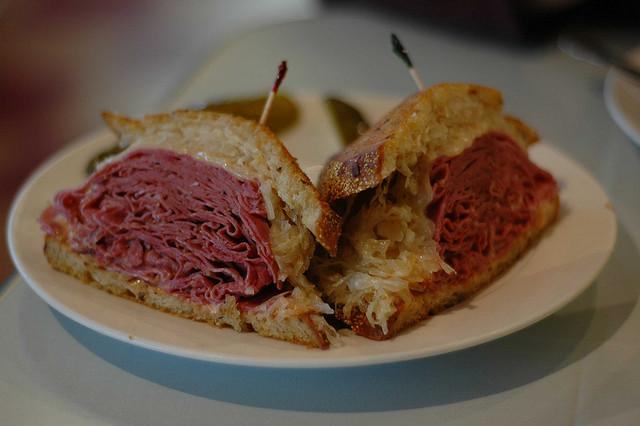What's the purpose of the little sticks? hold together 